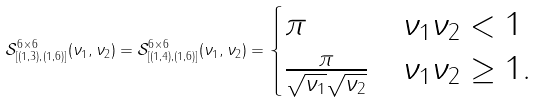Convert formula to latex. <formula><loc_0><loc_0><loc_500><loc_500>\mathcal { S } _ { [ ( 1 , 3 ) , ( 1 , 6 ) ] } ^ { 6 \times 6 } ( \nu _ { 1 } , \nu _ { 2 } ) = \mathcal { S } _ { [ ( 1 , 4 ) , ( 1 , 6 ) ] } ^ { 6 \times 6 } ( \nu _ { 1 } , \nu _ { 2 } ) = \begin{cases} \pi & \nu _ { 1 } \nu _ { 2 } < 1 \\ \frac { \pi } { \sqrt { \nu _ { 1 } } \sqrt { \nu _ { 2 } } } & \nu _ { 1 } \nu _ { 2 } \geq 1 . \end{cases}</formula> 